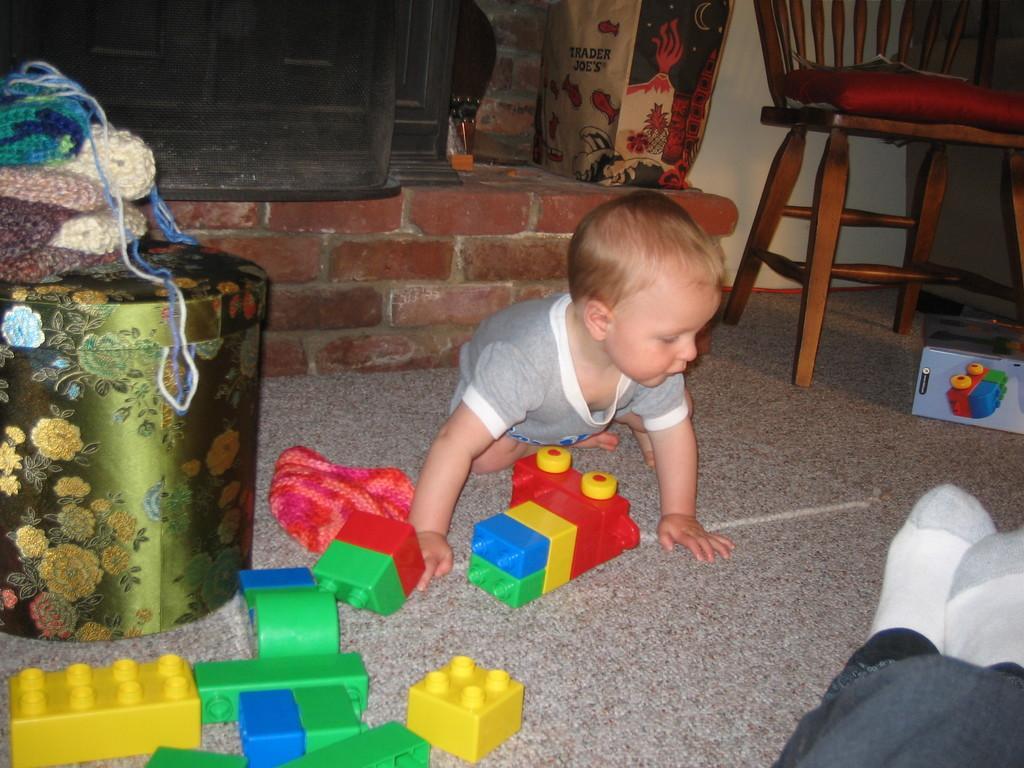Please provide a concise description of this image. In this image, there is a kid sitting on the ground and wearing clothes. There are some toys and container on the ground. There is a bag and chair in front of the wall. 